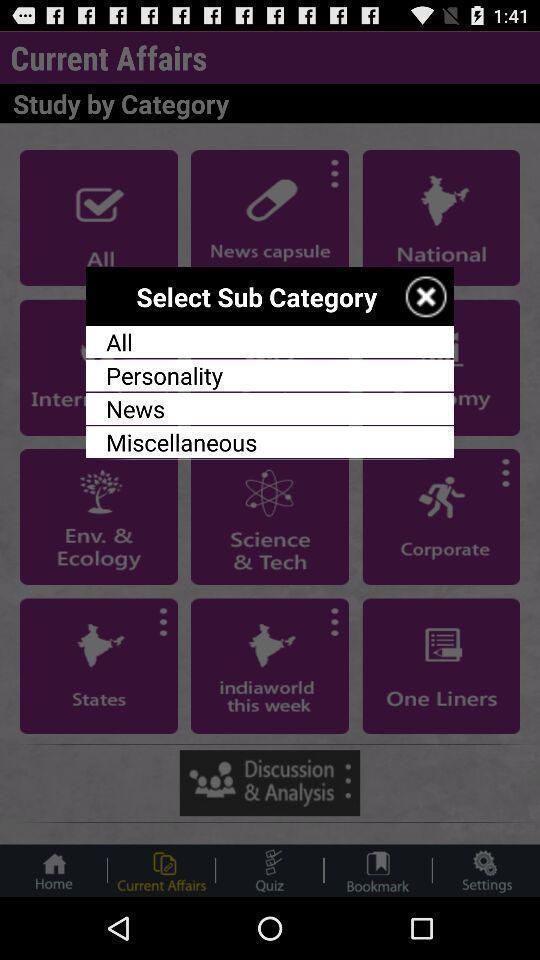Provide a description of this screenshot. Popup to select category in the exam preparing app. 